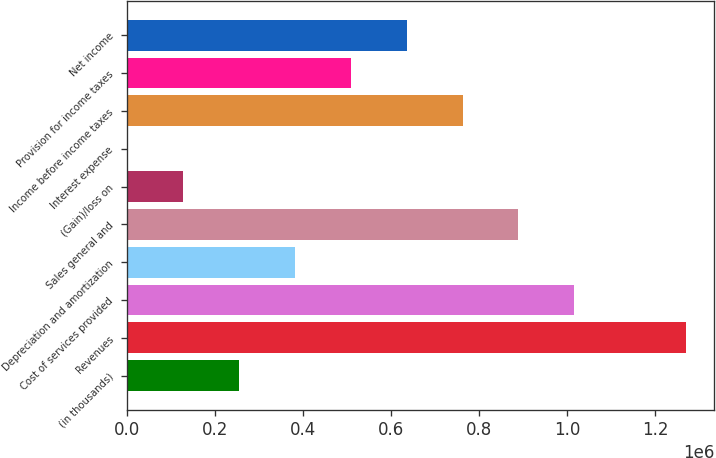<chart> <loc_0><loc_0><loc_500><loc_500><bar_chart><fcel>(in thousands)<fcel>Revenues<fcel>Cost of services provided<fcel>Depreciation and amortization<fcel>Sales general and<fcel>(Gain)/loss on<fcel>Interest expense<fcel>Income before income taxes<fcel>Provision for income taxes<fcel>Net income<nl><fcel>254193<fcel>1.27091e+06<fcel>1.01673e+06<fcel>381282<fcel>889640<fcel>127104<fcel>14<fcel>762551<fcel>508372<fcel>635462<nl></chart> 